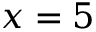<formula> <loc_0><loc_0><loc_500><loc_500>x = 5</formula> 